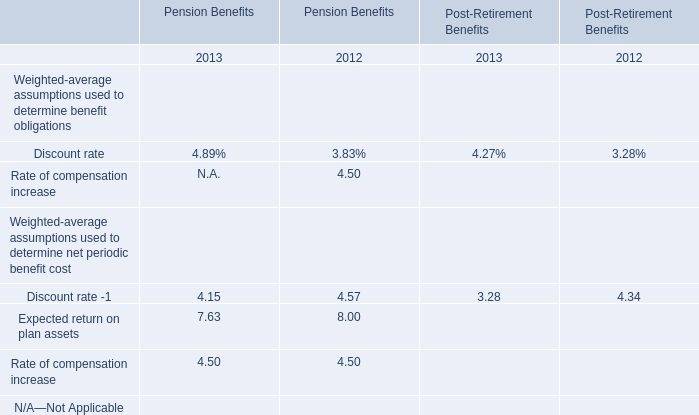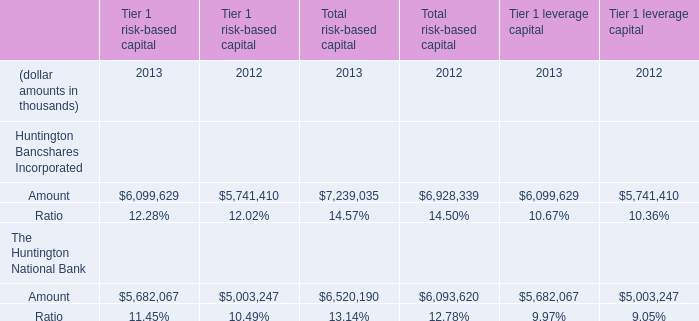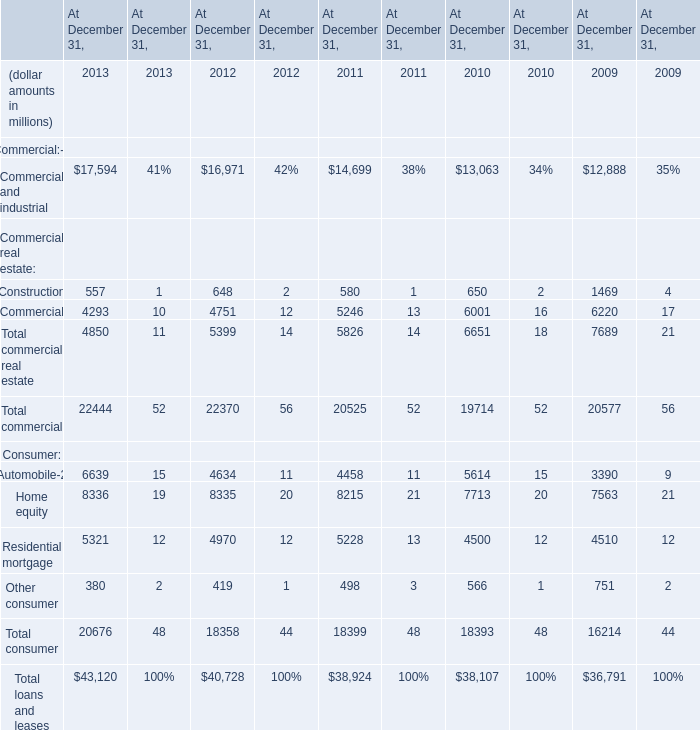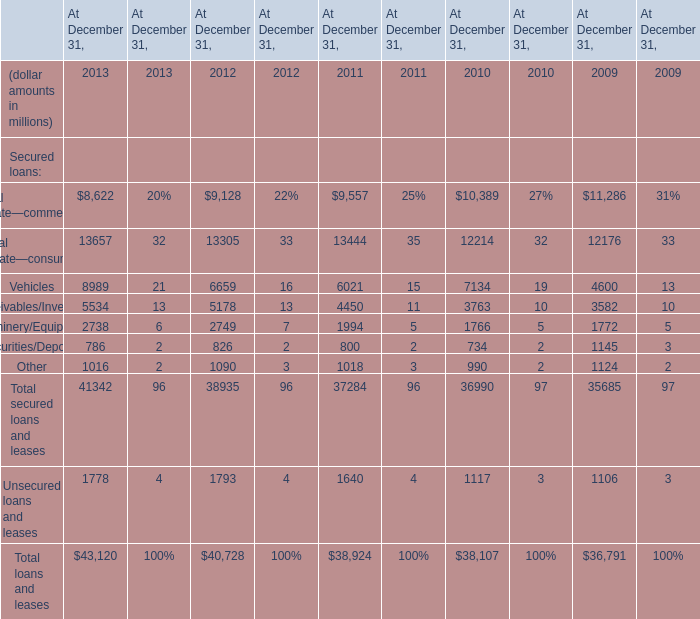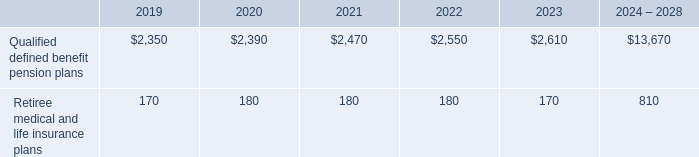If the amount of Total secured loans and leases on December 31 develops with the same increasing rate in 2011, what will it reach in 2012? (in million) 
Computations: (37284 * (1 + ((37284 - 36990) / 36990)))
Answer: 37580.33674. 